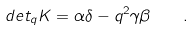<formula> <loc_0><loc_0><loc_500><loc_500>d e t _ { q } K = \alpha \delta - q ^ { 2 } \gamma \beta \quad .</formula> 